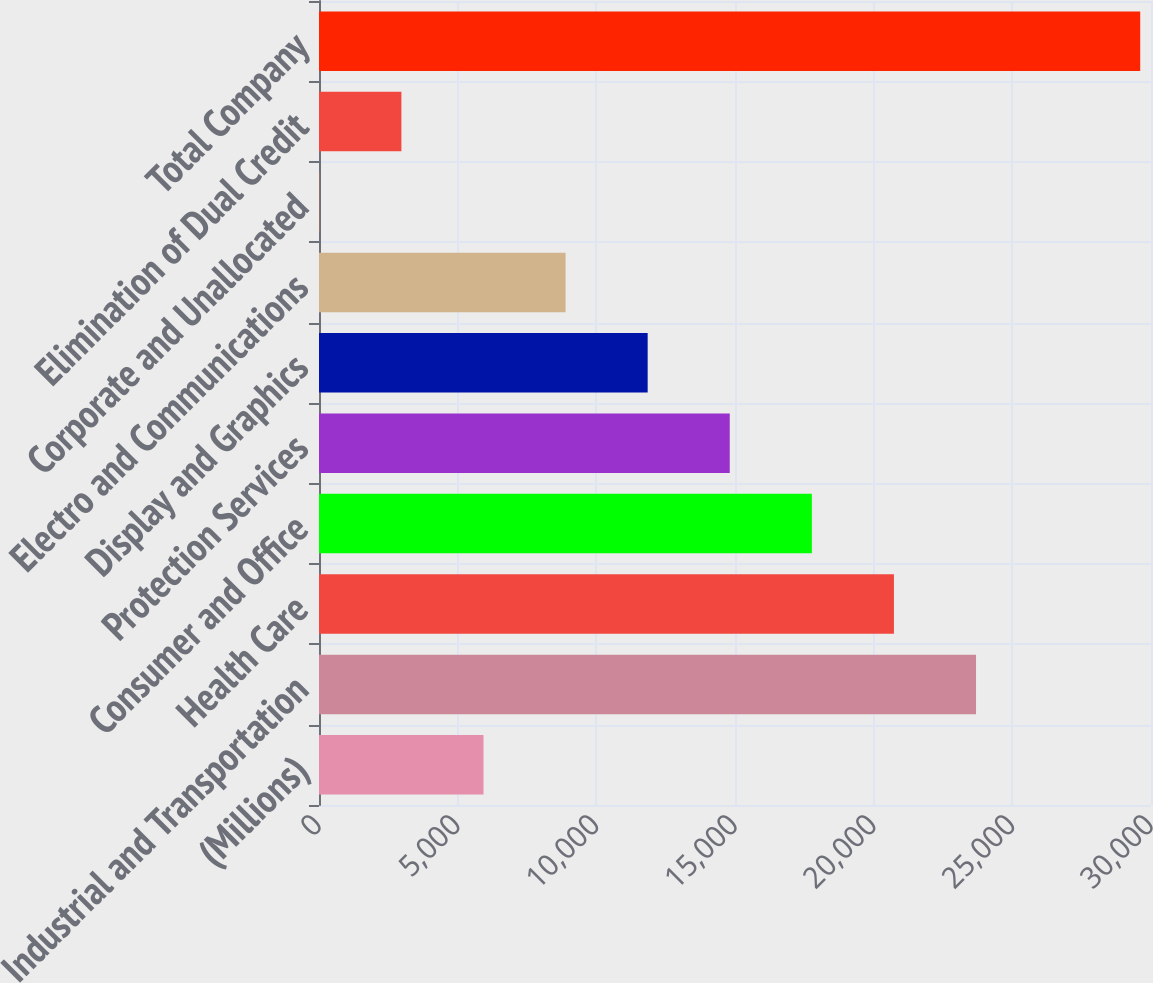Convert chart to OTSL. <chart><loc_0><loc_0><loc_500><loc_500><bar_chart><fcel>(Millions)<fcel>Industrial and Transportation<fcel>Health Care<fcel>Consumer and Office<fcel>Protection Services<fcel>Display and Graphics<fcel>Electro and Communications<fcel>Corporate and Unallocated<fcel>Elimination of Dual Credit<fcel>Total Company<nl><fcel>5931<fcel>23691<fcel>20731<fcel>17771<fcel>14811<fcel>11851<fcel>8891<fcel>11<fcel>2971<fcel>29611<nl></chart> 